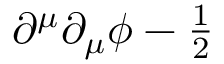Convert formula to latex. <formula><loc_0><loc_0><loc_500><loc_500>\partial ^ { \mu } \partial _ { \mu } \phi - { \frac { 1 } { 2 } }</formula> 